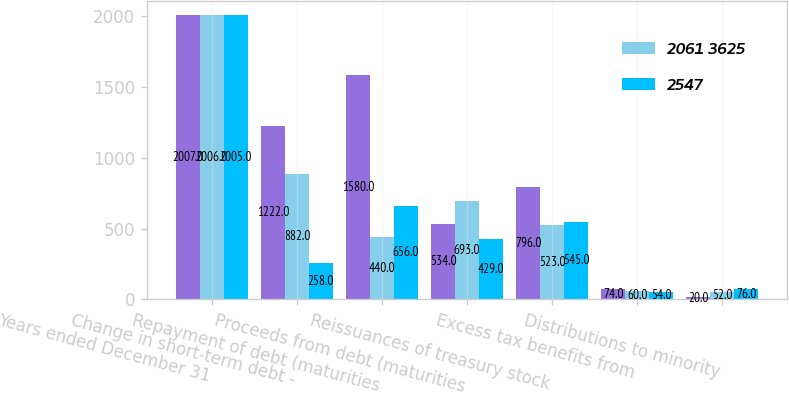<chart> <loc_0><loc_0><loc_500><loc_500><stacked_bar_chart><ecel><fcel>Years ended December 31<fcel>Change in short-term debt -<fcel>Repayment of debt (maturities<fcel>Proceeds from debt (maturities<fcel>Reissuances of treasury stock<fcel>Excess tax benefits from<fcel>Distributions to minority<nl><fcel>nan<fcel>2007<fcel>1222<fcel>1580<fcel>534<fcel>796<fcel>74<fcel>20<nl><fcel>2061 3625<fcel>2006<fcel>882<fcel>440<fcel>693<fcel>523<fcel>60<fcel>52<nl><fcel>2547<fcel>2005<fcel>258<fcel>656<fcel>429<fcel>545<fcel>54<fcel>76<nl></chart> 